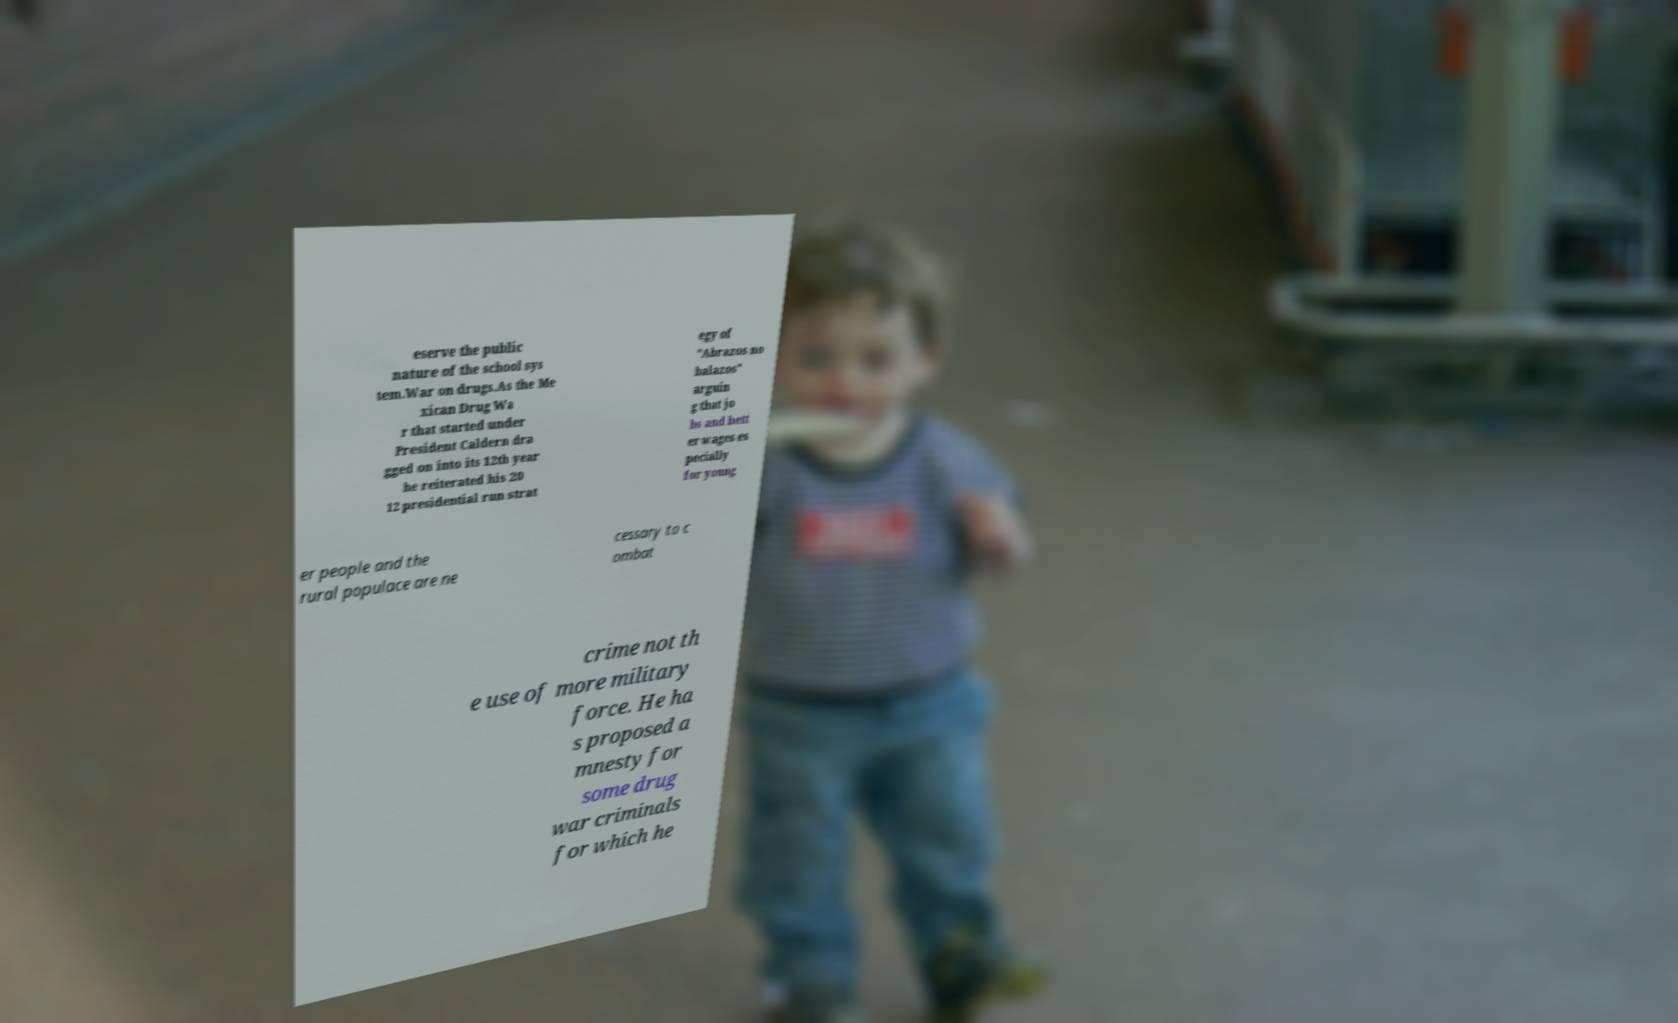What messages or text are displayed in this image? I need them in a readable, typed format. eserve the public nature of the school sys tem.War on drugs.As the Me xican Drug Wa r that started under President Caldern dra gged on into its 12th year he reiterated his 20 12 presidential run strat egy of "Abrazos no balazos" arguin g that jo bs and bett er wages es pecially for young er people and the rural populace are ne cessary to c ombat crime not th e use of more military force. He ha s proposed a mnesty for some drug war criminals for which he 